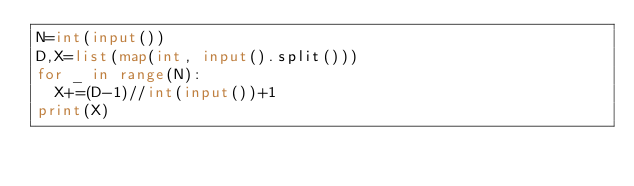Convert code to text. <code><loc_0><loc_0><loc_500><loc_500><_Python_>N=int(input())
D,X=list(map(int, input().split()))
for _ in range(N):
  X+=(D-1)//int(input())+1
print(X)</code> 